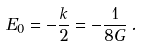Convert formula to latex. <formula><loc_0><loc_0><loc_500><loc_500>E _ { 0 } = - \frac { k } { 2 } = - \frac { 1 } { 8 G } \, .</formula> 